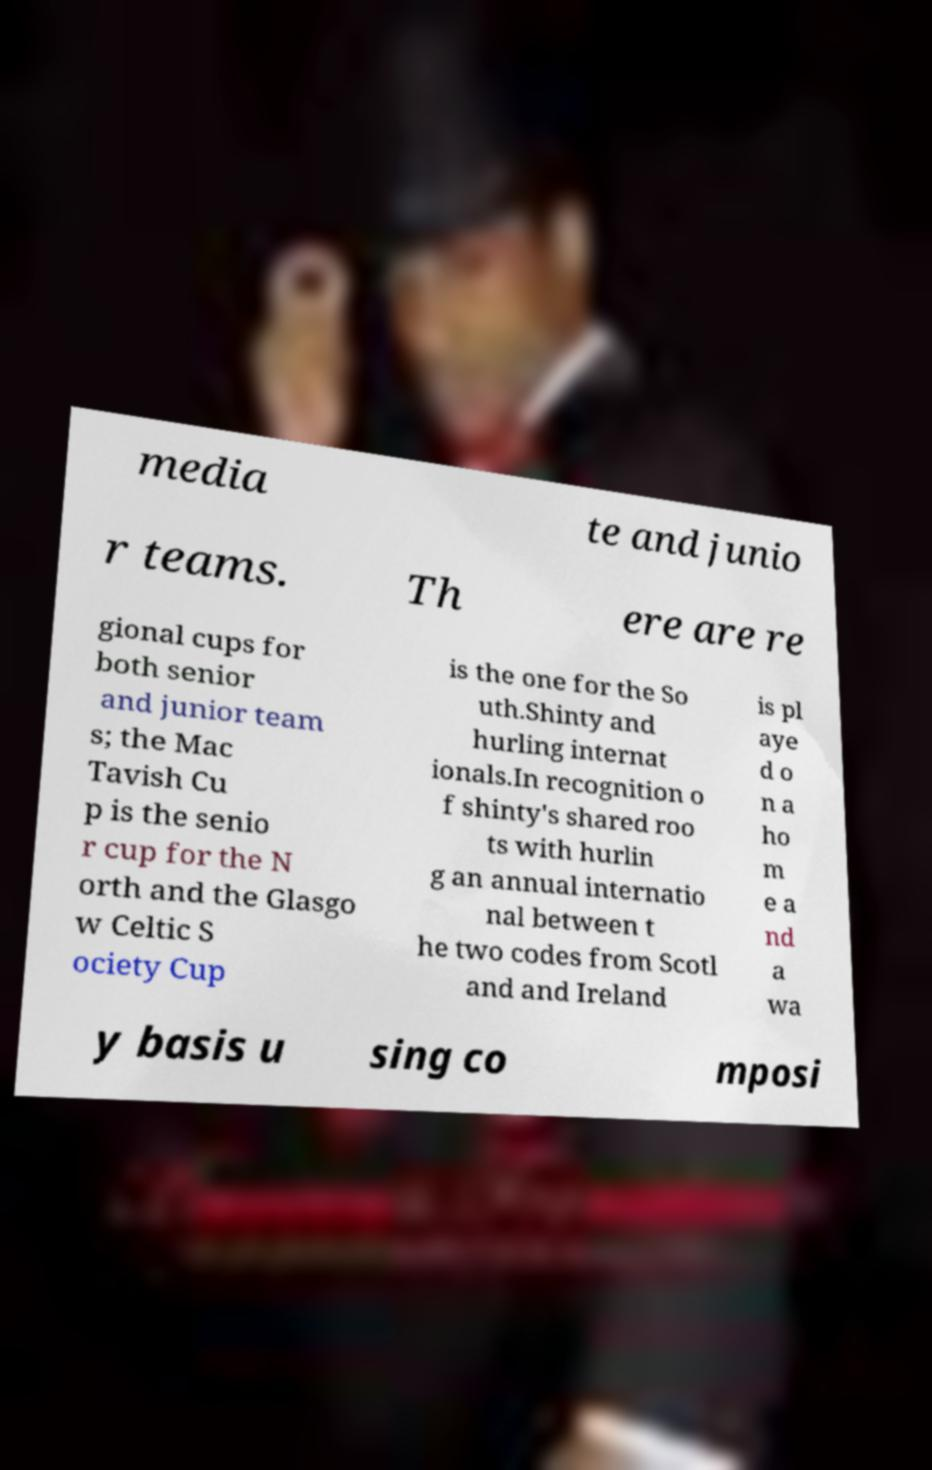Could you assist in decoding the text presented in this image and type it out clearly? media te and junio r teams. Th ere are re gional cups for both senior and junior team s; the Mac Tavish Cu p is the senio r cup for the N orth and the Glasgo w Celtic S ociety Cup is the one for the So uth.Shinty and hurling internat ionals.In recognition o f shinty's shared roo ts with hurlin g an annual internatio nal between t he two codes from Scotl and and Ireland is pl aye d o n a ho m e a nd a wa y basis u sing co mposi 